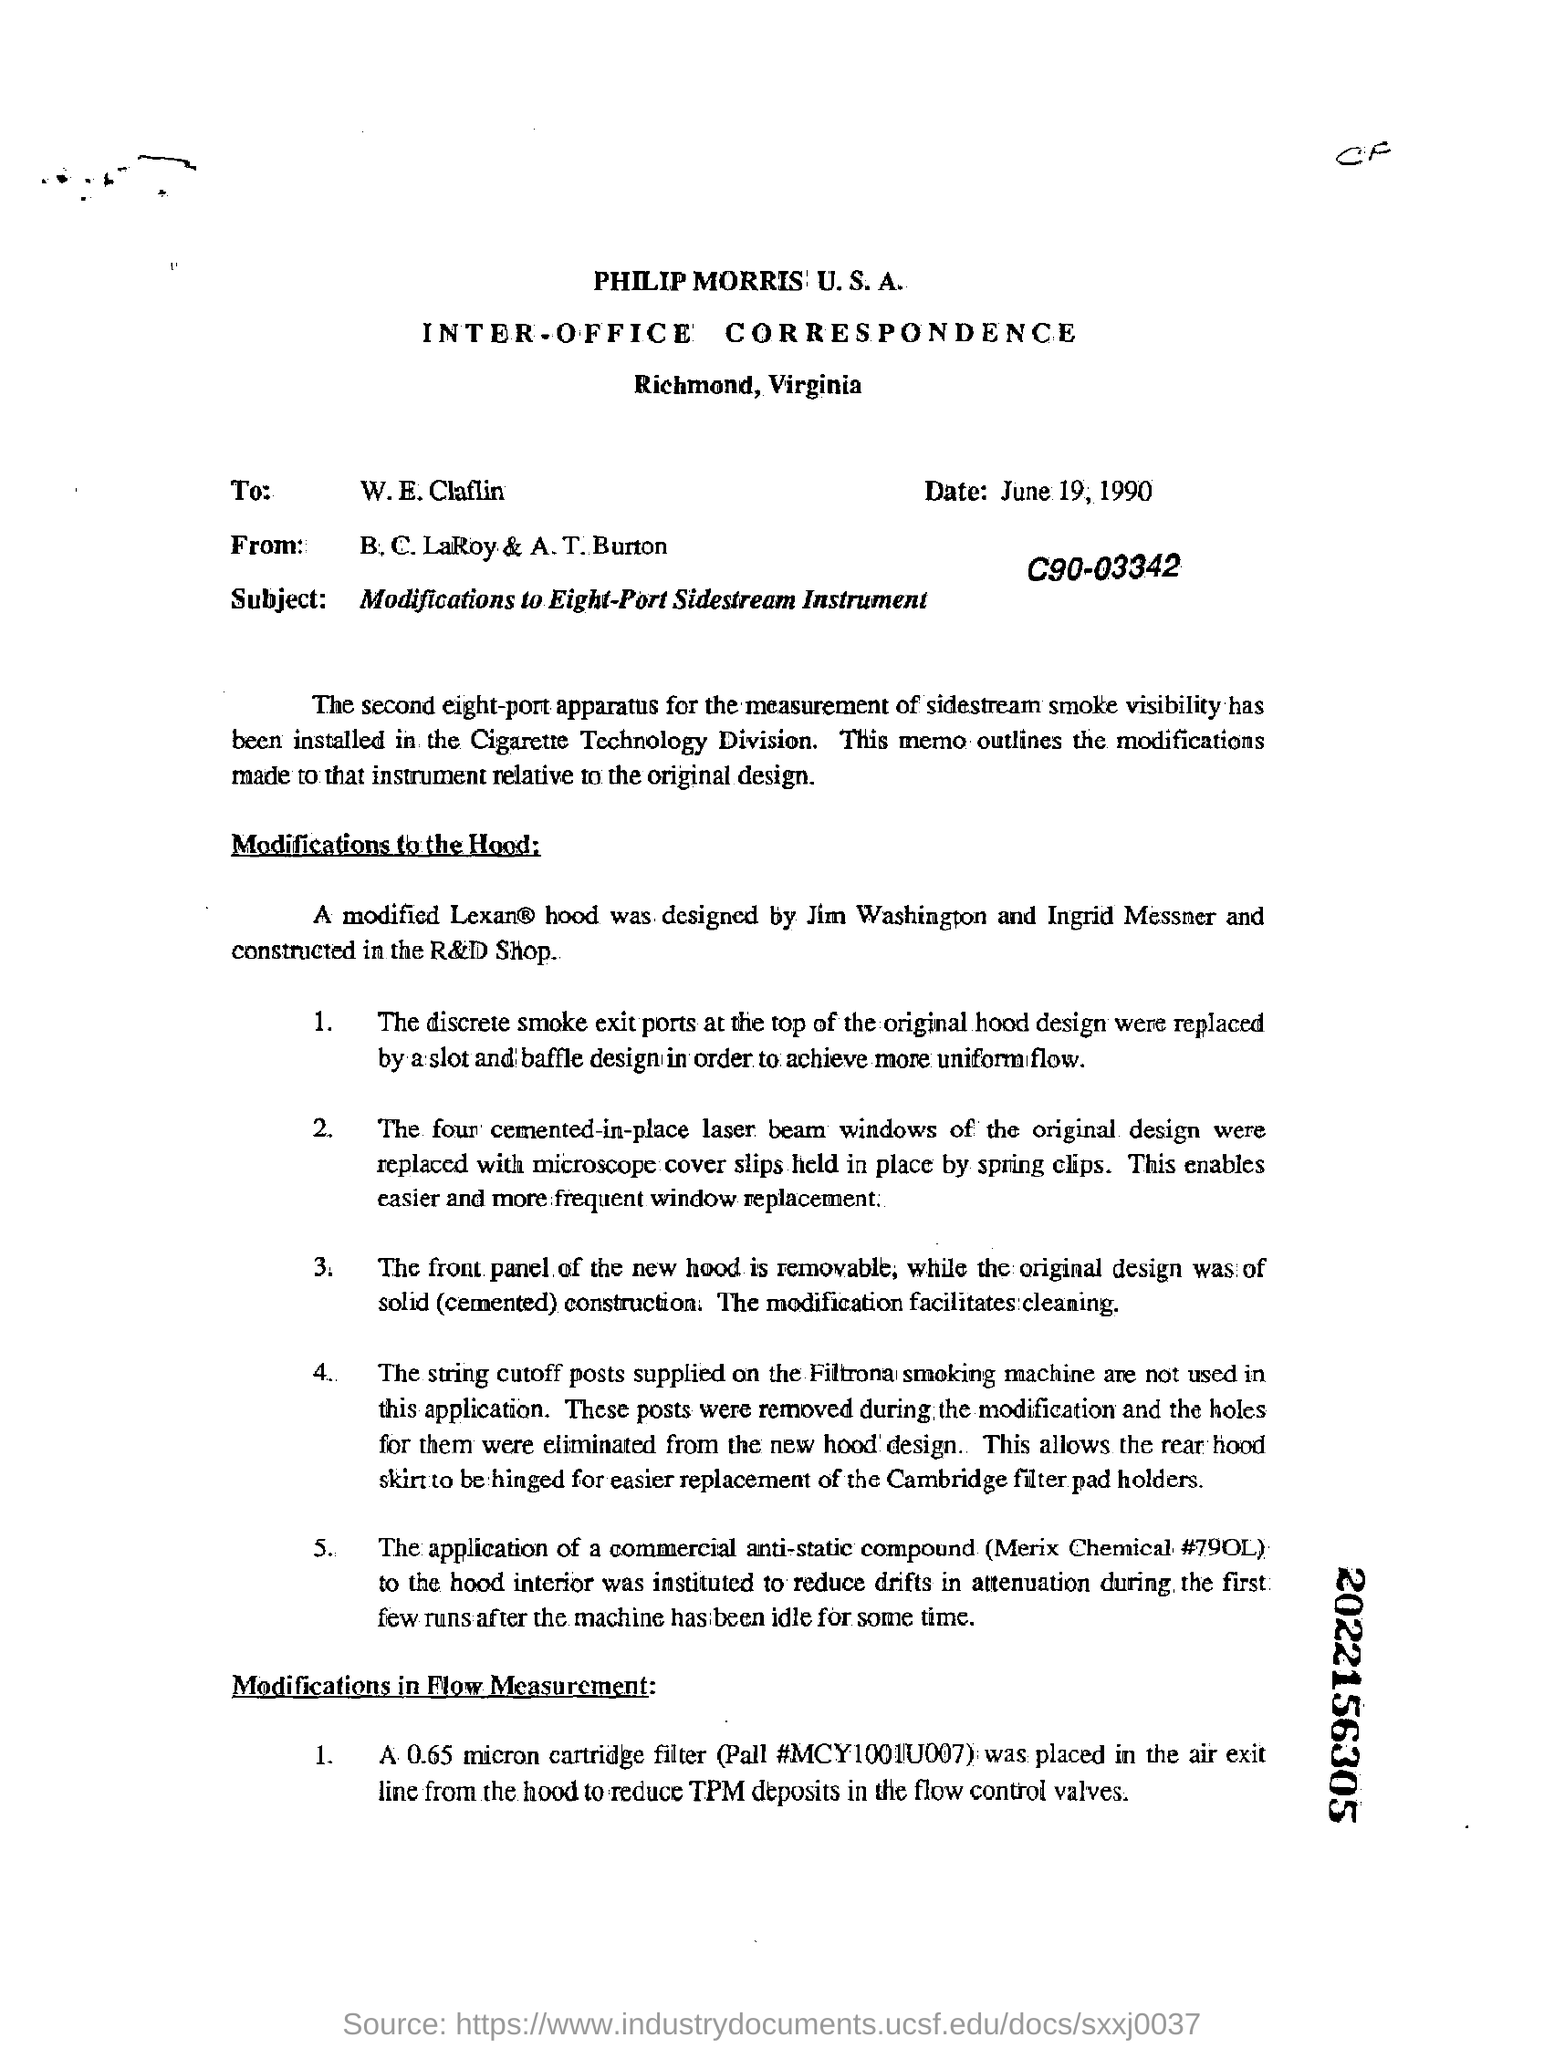Outline some significant characteristics in this image. The date mentioned in the document is June 19, 1990. The subject of the document is the modifications to an Eight-Port Sidestream Instrument. The letter is addressed to W.E.Claflin. The date mentioned is June 19, 1990. 